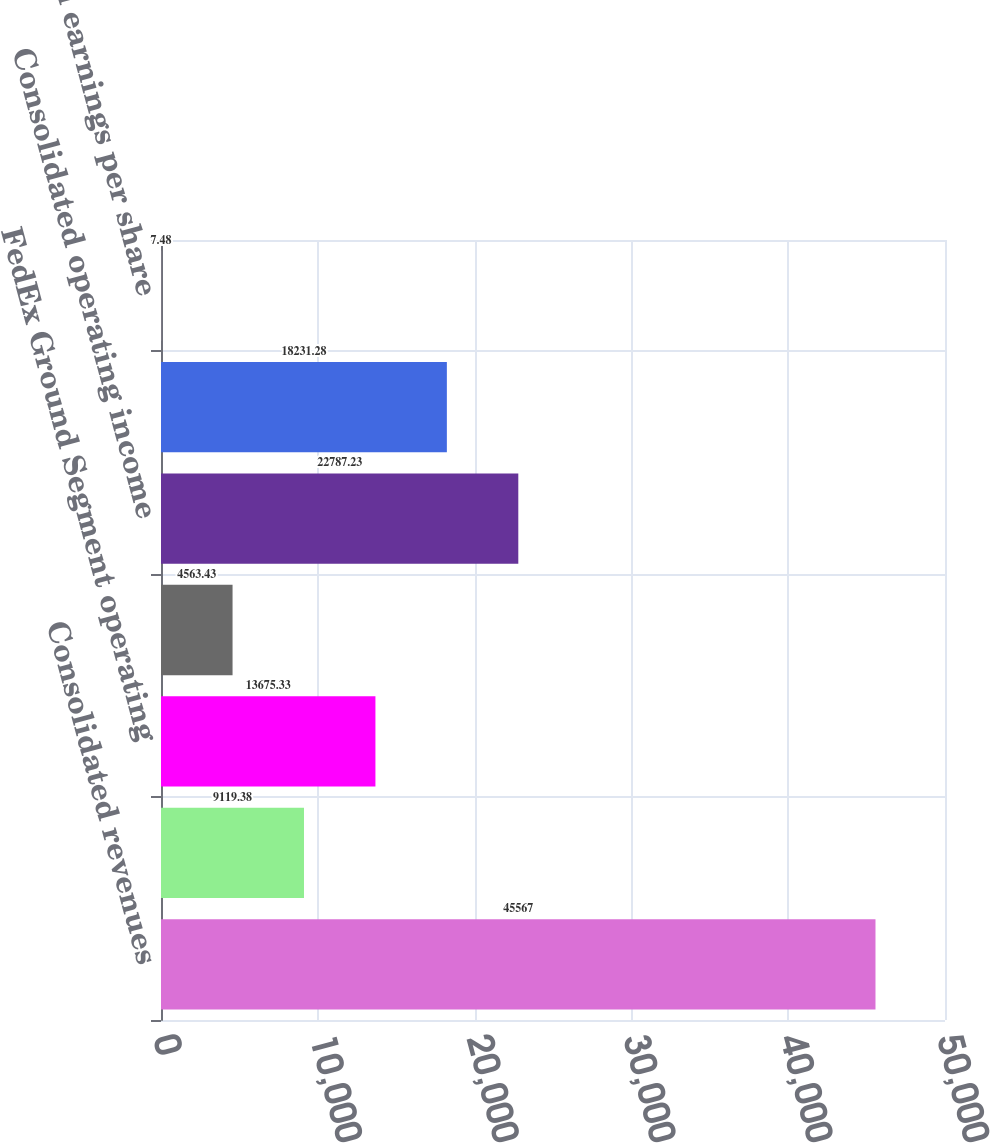Convert chart to OTSL. <chart><loc_0><loc_0><loc_500><loc_500><bar_chart><fcel>Consolidated revenues<fcel>FedEx Express Segment<fcel>FedEx Ground Segment operating<fcel>FedEx Freight Segment<fcel>Consolidated operating income<fcel>Consolidated net income (3)<fcel>Diluted earnings per share<nl><fcel>45567<fcel>9119.38<fcel>13675.3<fcel>4563.43<fcel>22787.2<fcel>18231.3<fcel>7.48<nl></chart> 